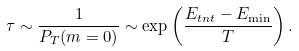<formula> <loc_0><loc_0><loc_500><loc_500>\tau \sim \frac { 1 } { P _ { T } ( m = 0 ) } \sim \exp \left ( \frac { E _ { t n t } - E _ { \min } } { T } \right ) .</formula> 